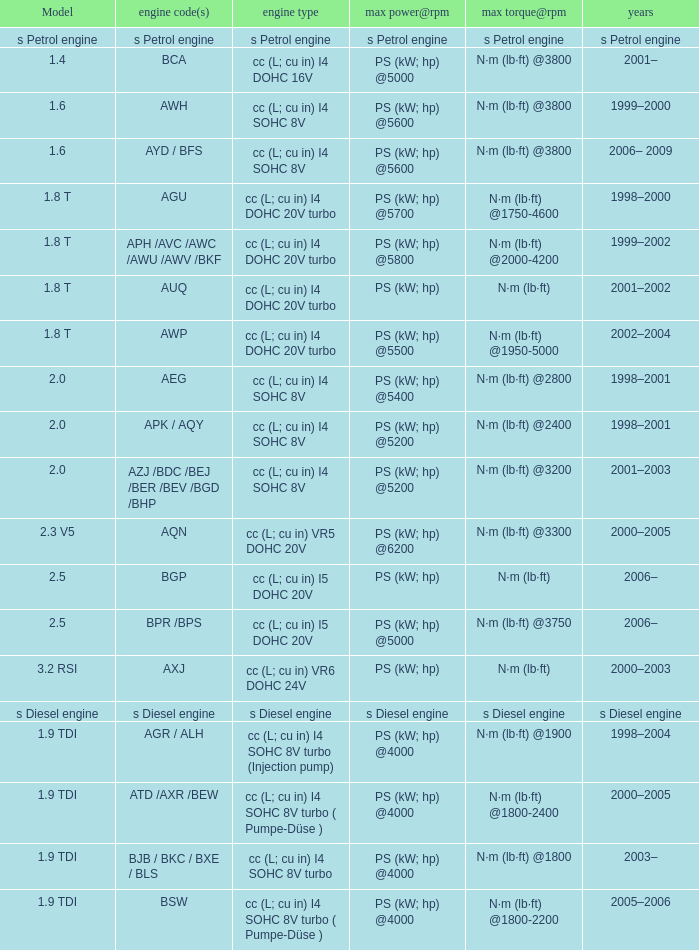5 model and a top power@rpm of ps (kw; hp) @5000? N·m (lb·ft) @3750. 